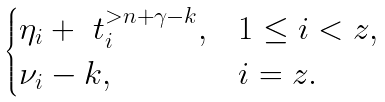Convert formula to latex. <formula><loc_0><loc_0><loc_500><loc_500>\begin{cases} \eta _ { i } + \ t _ { i } ^ { > n + \gamma - k } , & 1 \leq i < z , \\ \nu _ { i } - k , & i = z . \end{cases}</formula> 